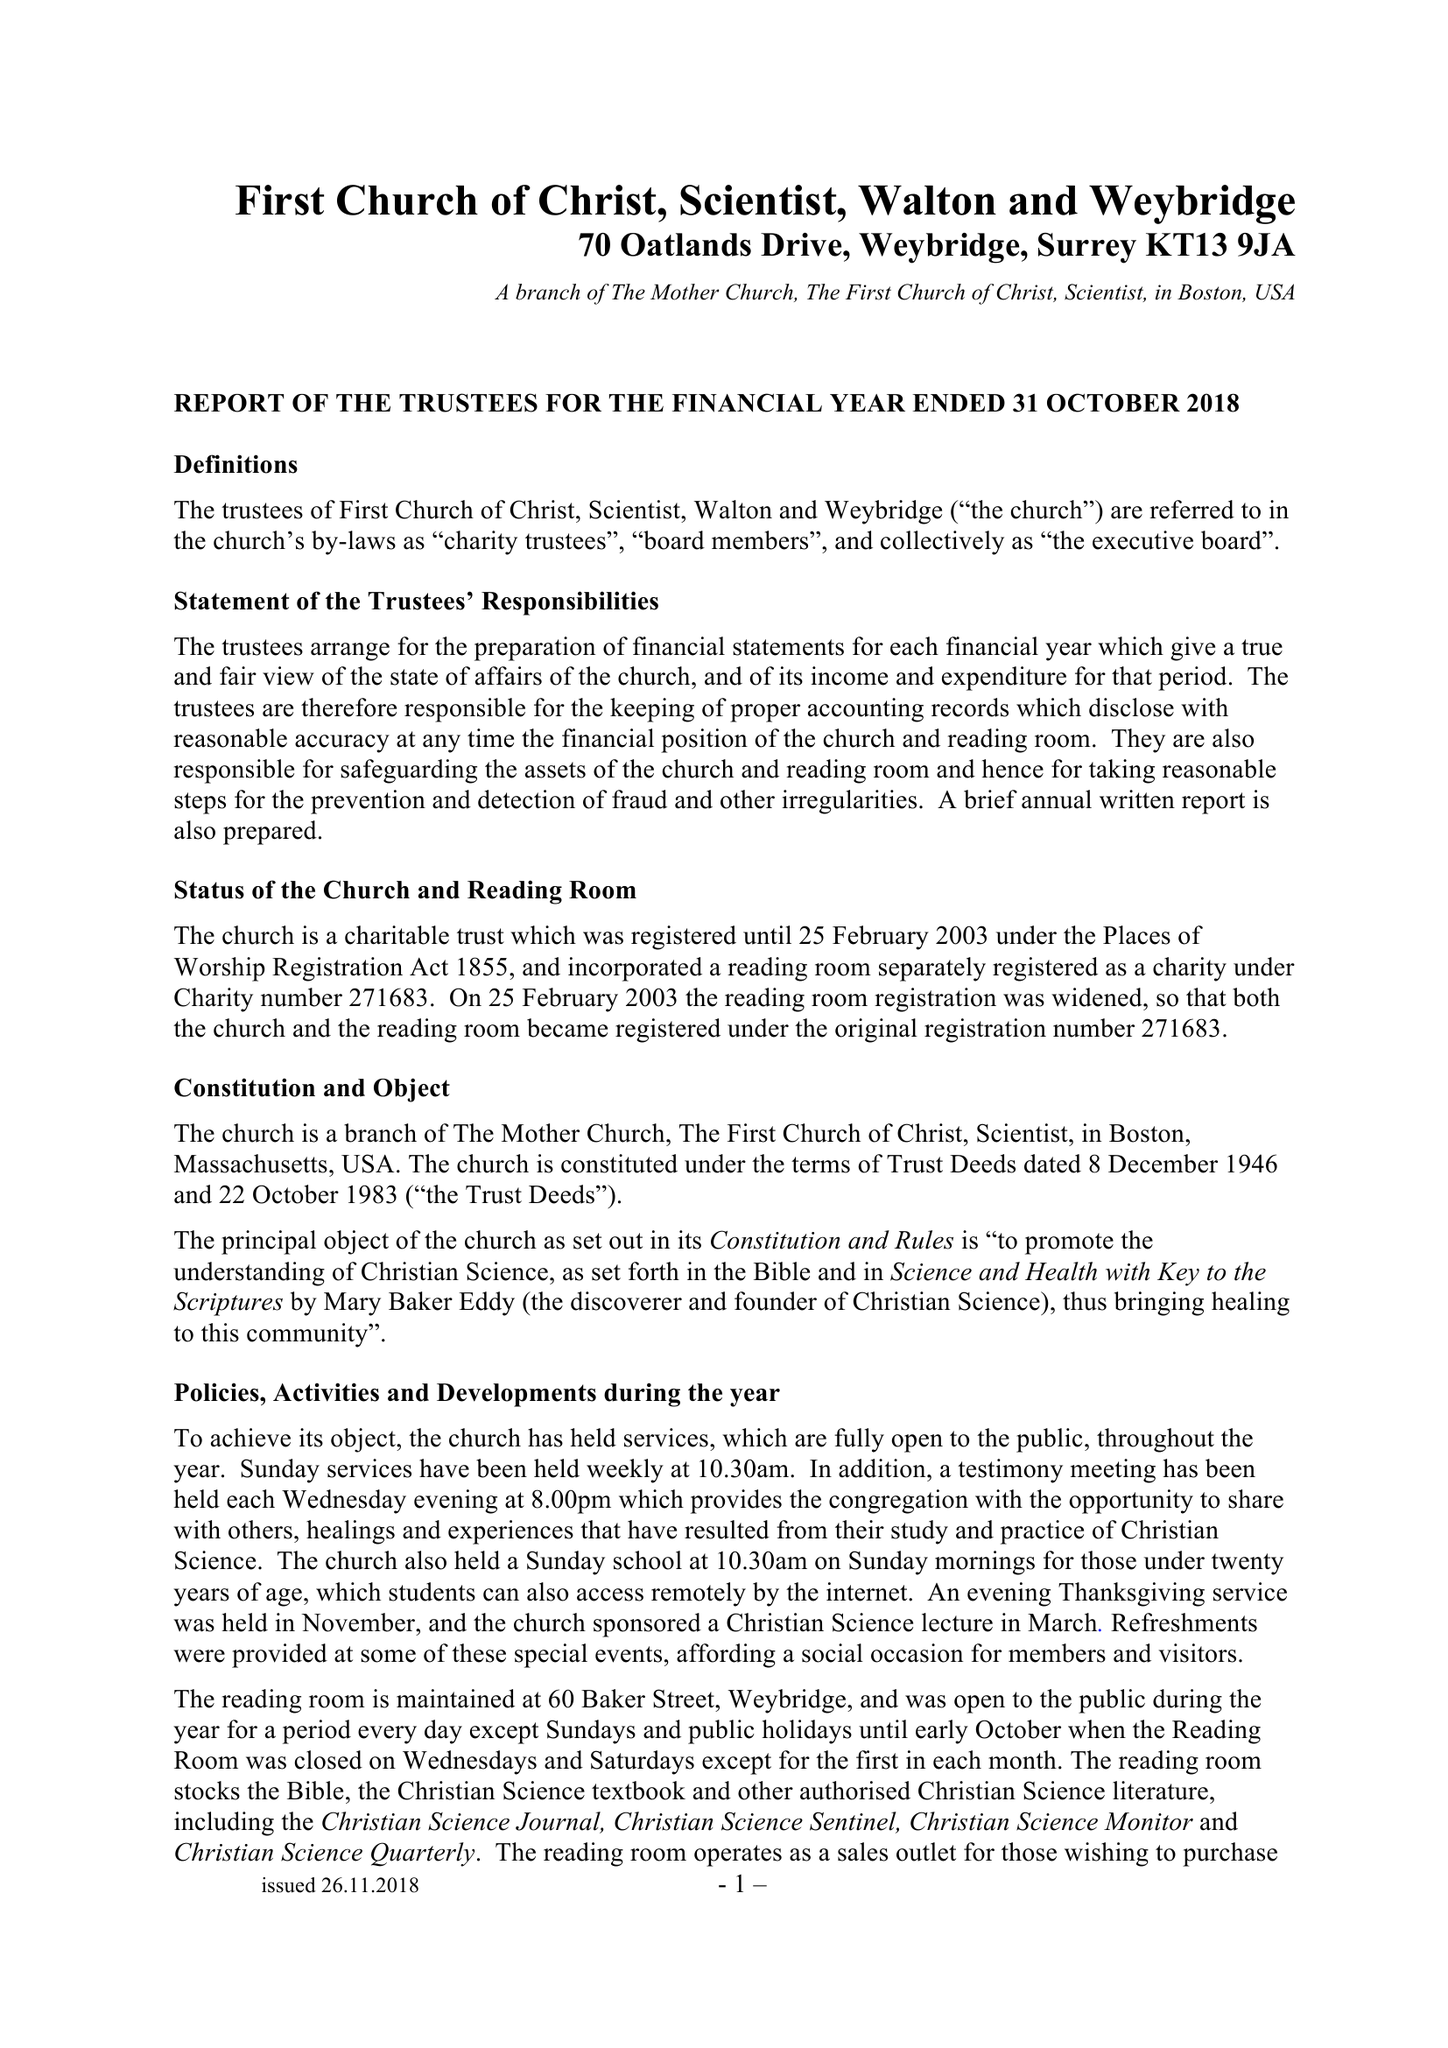What is the value for the report_date?
Answer the question using a single word or phrase. 2018-10-31 